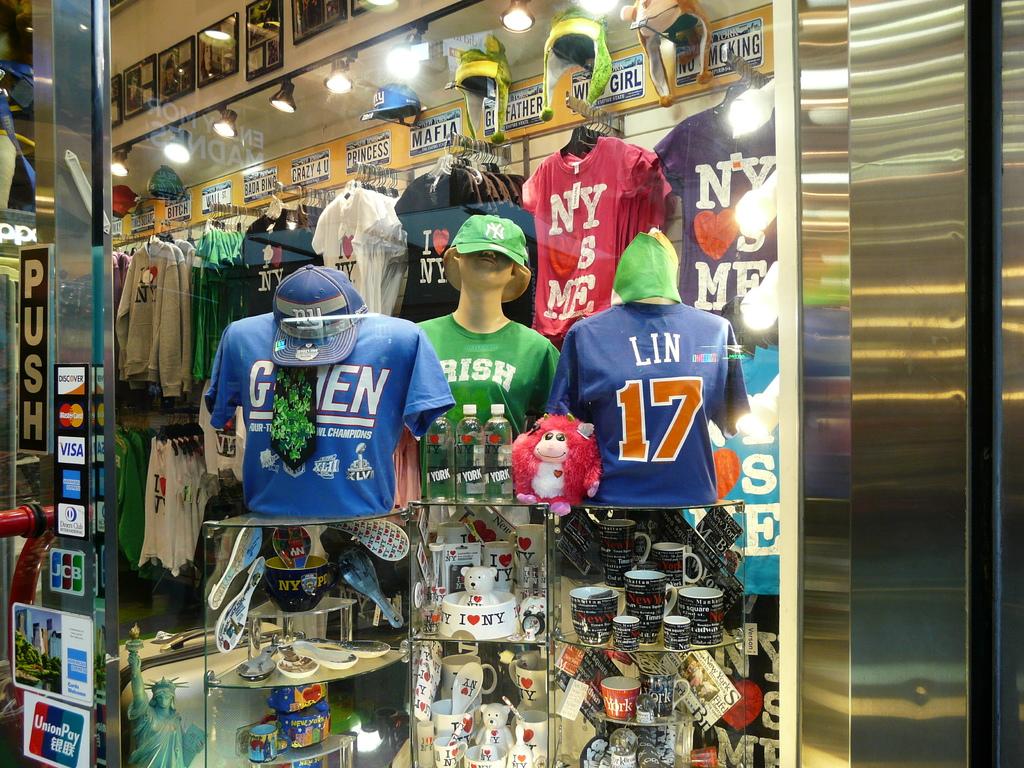What's the name on the back of the jersey that has the number 17?
Provide a short and direct response. Lin. What is the number on the shirt with lin?
Provide a short and direct response. 17. 